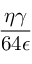Convert formula to latex. <formula><loc_0><loc_0><loc_500><loc_500>\frac { \eta \gamma } { 6 4 \epsilon }</formula> 